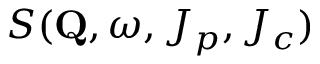<formula> <loc_0><loc_0><loc_500><loc_500>S ( Q , \omega , J _ { p } , J _ { c } )</formula> 